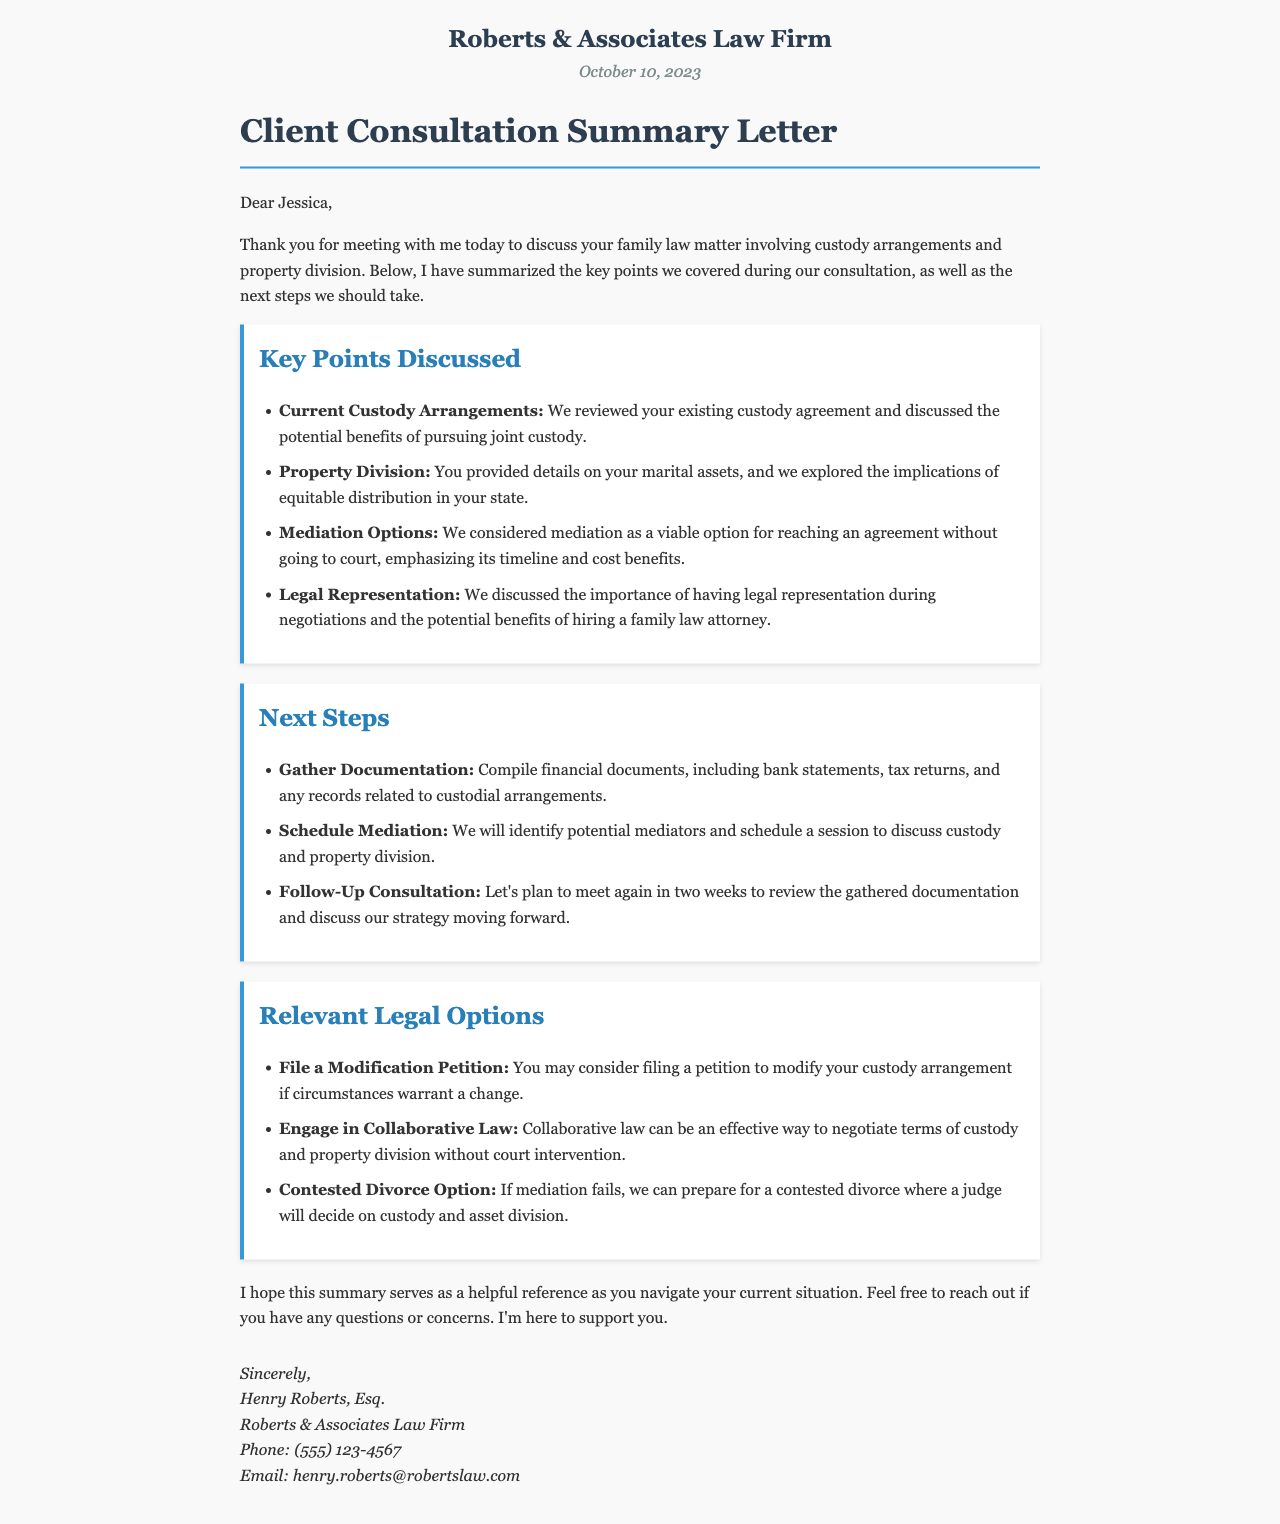What is the date of the letter? The date is mentioned at the top of the letter, indicating when it was written.
Answer: October 10, 2023 Who is the recipient of the letter? The letter is addressed to a specific individual, indicating the client involved in the matter.
Answer: Jessica What is the first key point discussed? The first item in the list of key points summarizes a discussion regarding custody, identifying the starting topic of conversation.
Answer: Current Custody Arrangements What is one of the next steps mentioned? One of the steps outlines actions the client needs to take following the meeting for their case preparation.
Answer: Gather Documentation What is one legal option available mentioned in the letter? This option indicates a potential action the client may take regarding custody arrangements and the legal process.
Answer: File a Modification Petition What is the title of the document? The title reveals the nature of the correspondence and provides context for the content within.
Answer: Client Consultation Summary Letter Who is the attorney signing the letter? The signature section identifies the legal professional representing the client and providing guidance in this matter.
Answer: Henry Roberts, Esq 